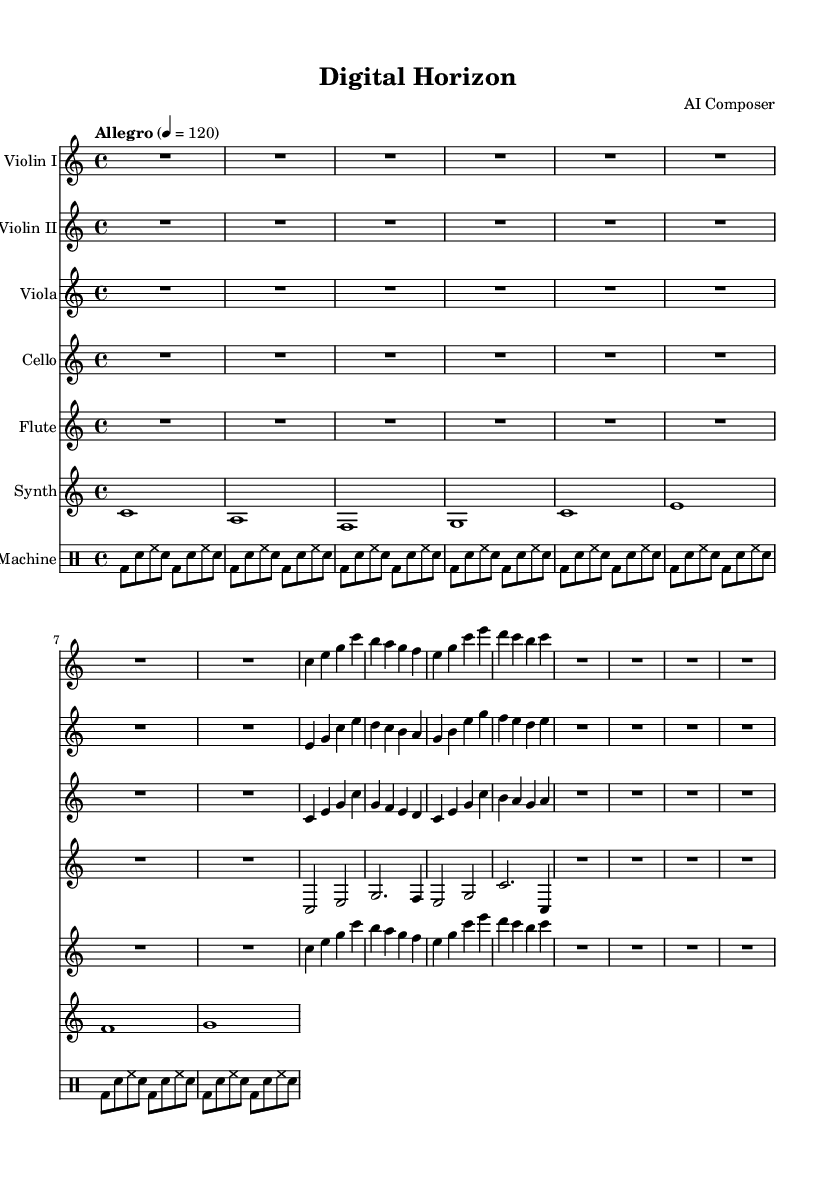what is the key signature of this music? The key signature is C major, which has no sharps or flats.
Answer: C major what is the time signature of this music? The time signature is indicated at the beginning of the staff which shows four beats per measure.
Answer: 4/4 what is the tempo marking for this piece? The tempo marking shown indicates a fast pace, typically around 120 beats per minute.
Answer: Allegro how many measures does the synthesizer part contain? The synthesizer part consists of 16 individual notes showing sustained sounds and rests combined with rhythmic values.
Answer: 16 which instrument plays the highest pitch in this symphony? By examining the range of each instrument, the flute generally reaches a higher pitch than the others' lines.
Answer: Flute what is the function of the drum machine in this composition? The drum machine provides a rhythmic foundation that complements the orchestral parts, featuring a repeating pattern of bass and snare sounds.
Answer: Rhythmic foundation what electronic element is incorporated in this symphony? The synthesized sounds provided by the synthesizer add a modern layer to the overall soundscape of the piece.
Answer: Synthesizer 